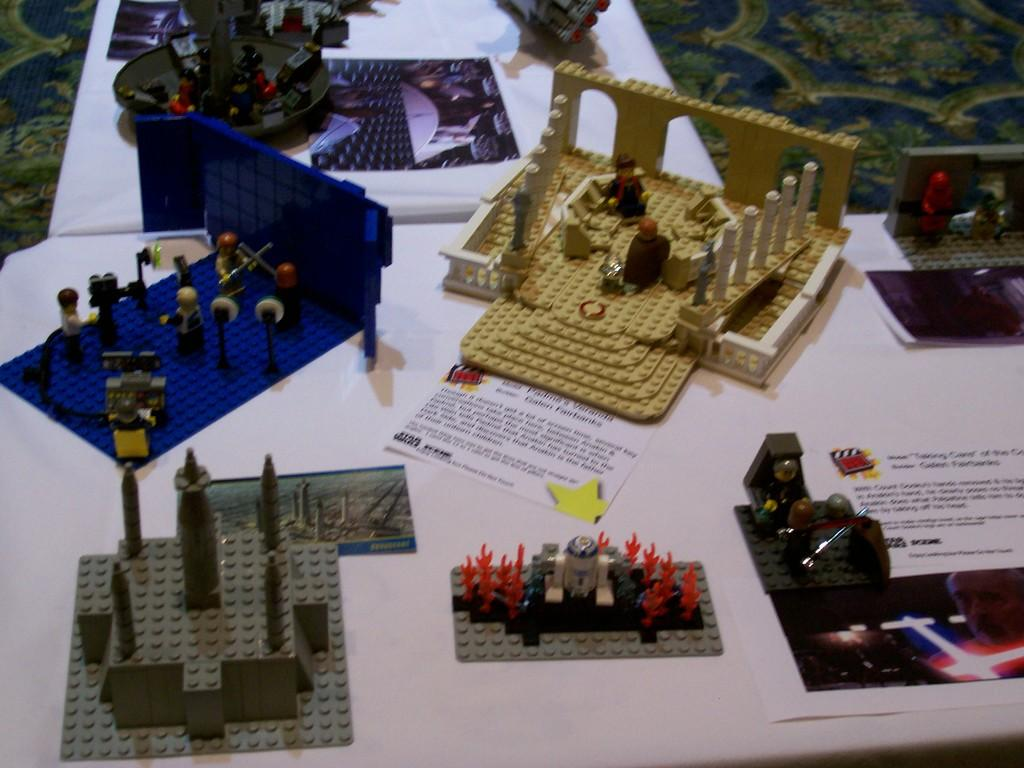What type of furniture is in the image? There is a table in the image. What is placed on the table? Posters and toys are on the table. What can be seen on the floor in the image? There is a mat on the floor. Can you describe the floor's condition? The floor is visible in the image, but there is no specific detail about its condition. What type of rifle is leaning against the table in the image? There is no rifle present in the image; only posters, toys, a table, and a mat on the floor are visible. 